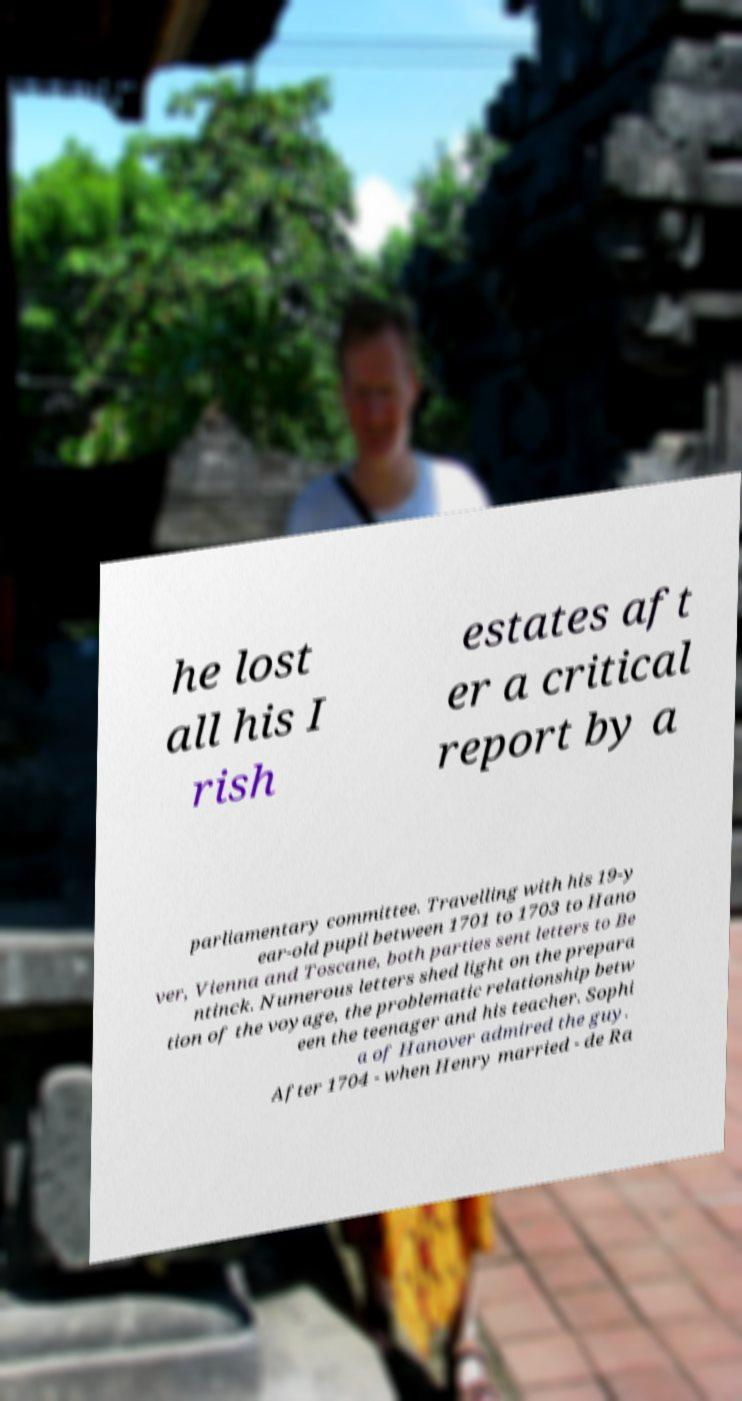For documentation purposes, I need the text within this image transcribed. Could you provide that? he lost all his I rish estates aft er a critical report by a parliamentary committee. Travelling with his 19-y ear-old pupil between 1701 to 1703 to Hano ver, Vienna and Toscane, both parties sent letters to Be ntinck. Numerous letters shed light on the prepara tion of the voyage, the problematic relationship betw een the teenager and his teacher. Sophi a of Hanover admired the guy. After 1704 - when Henry married - de Ra 